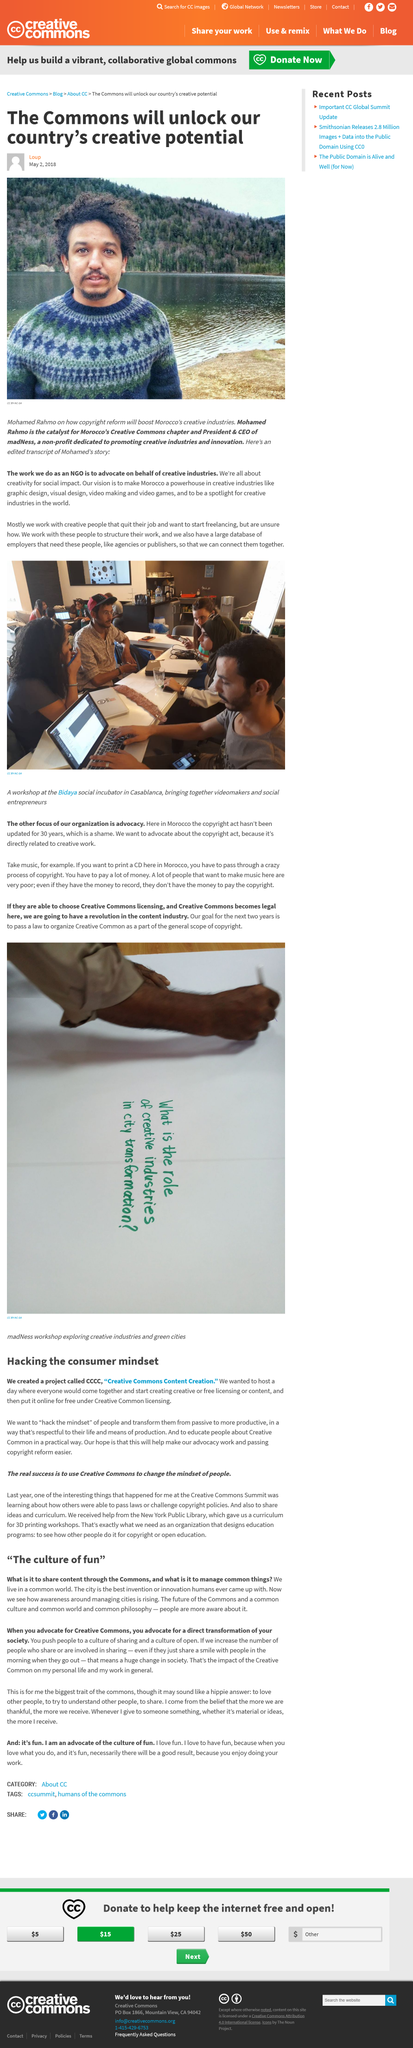Mention a couple of crucial points in this snapshot. The article image features Mohamed Rahmo. As stated in this text, the city is the most outstanding invention or innovation that humans have ever created. Mohamed Rahmo is the Catalyst for the Creative Commons chapter and the President and CEO of madNess. This project aims to transform people by shifting their mindset from passive to a more productive one. The increasing trend of people sharing, whether it be a smile or something more, has the potential to significantly transform society for the better. 